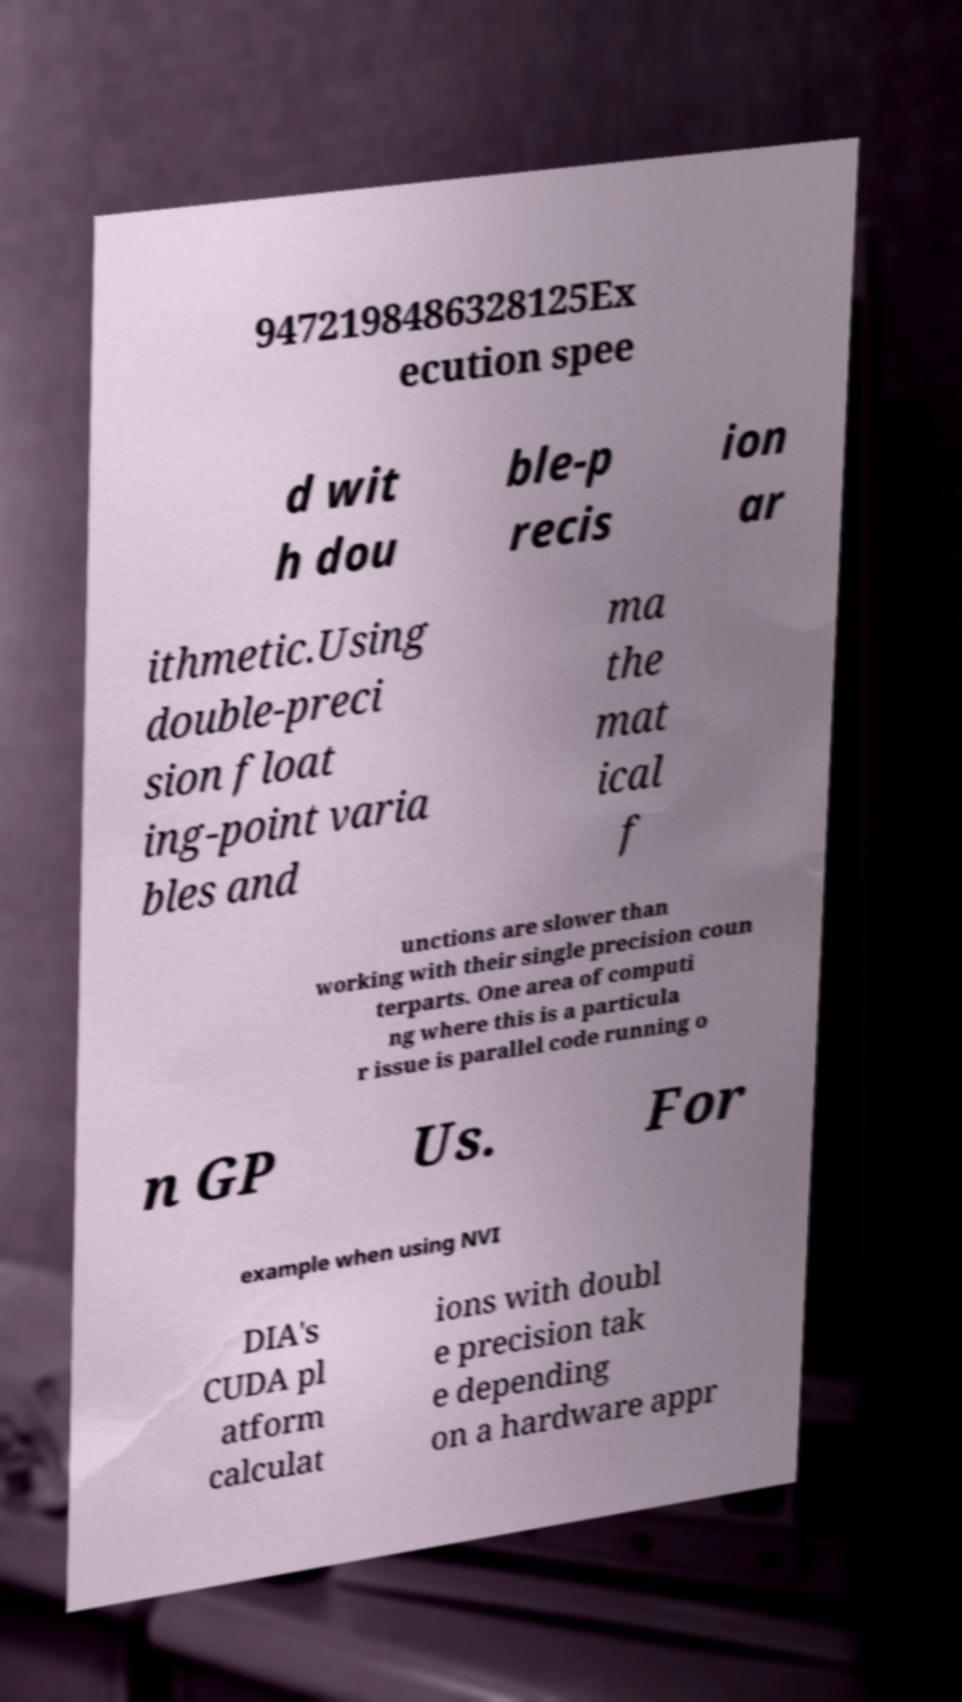Please read and relay the text visible in this image. What does it say? 9472198486328125Ex ecution spee d wit h dou ble-p recis ion ar ithmetic.Using double-preci sion float ing-point varia bles and ma the mat ical f unctions are slower than working with their single precision coun terparts. One area of computi ng where this is a particula r issue is parallel code running o n GP Us. For example when using NVI DIA's CUDA pl atform calculat ions with doubl e precision tak e depending on a hardware appr 